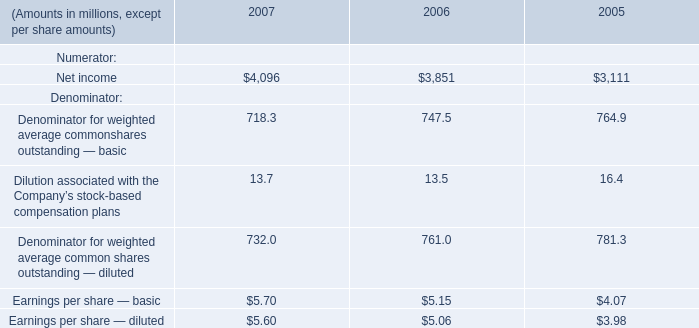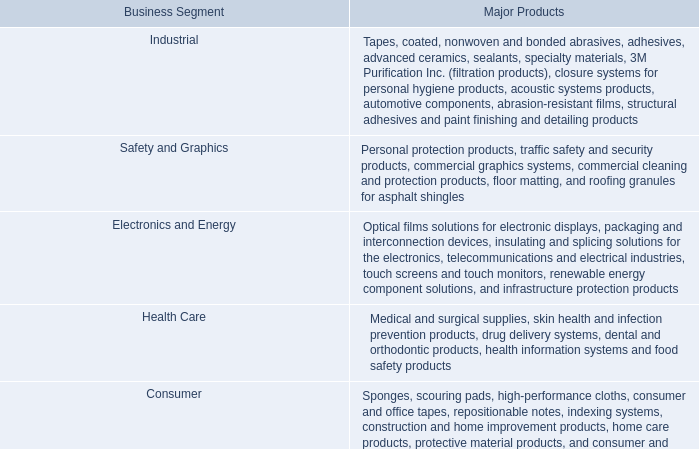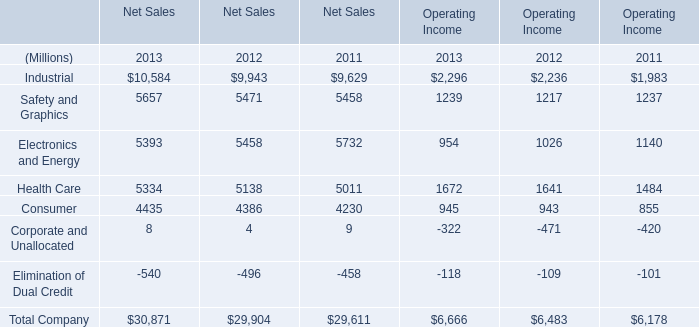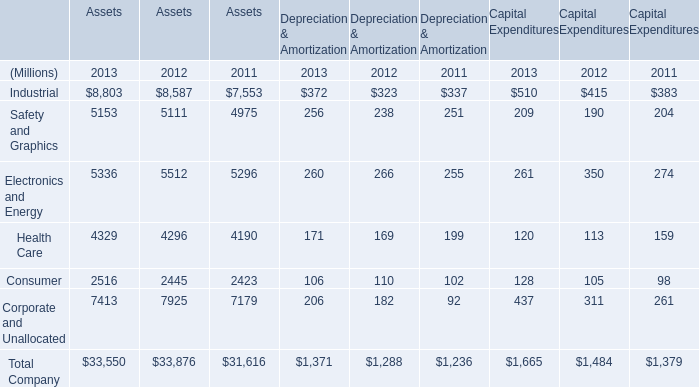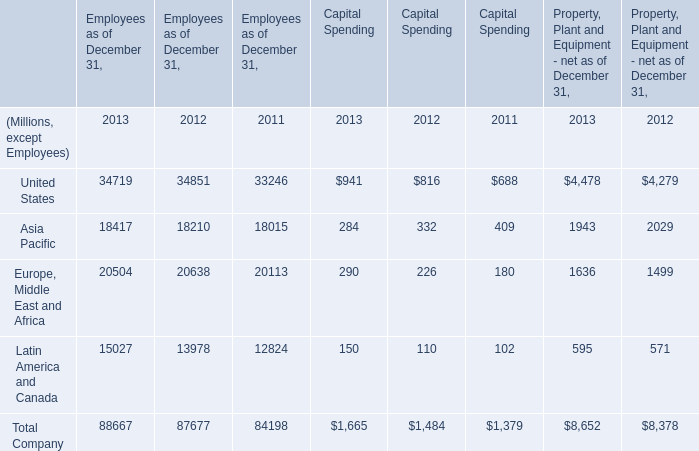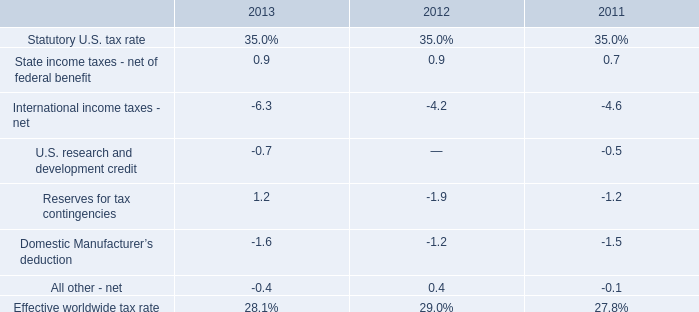what's the total amount of Net income of 2005, and Consumer of Assets 2012 ? 
Computations: (3111.0 + 2445.0)
Answer: 5556.0. 